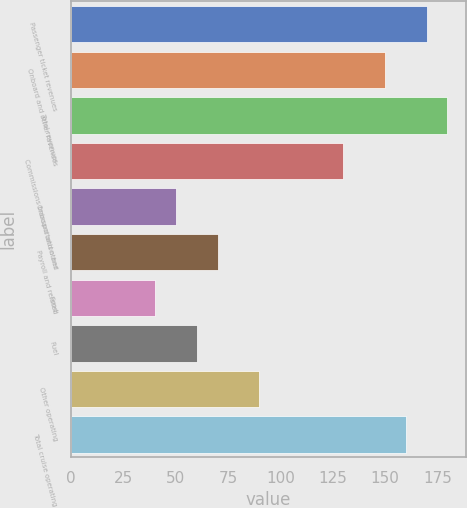Convert chart to OTSL. <chart><loc_0><loc_0><loc_500><loc_500><bar_chart><fcel>Passenger ticket revenues<fcel>Onboard and other revenues<fcel>Total revenues<fcel>Commissions transportation and<fcel>Onboard and other<fcel>Payroll and related<fcel>Food<fcel>Fuel<fcel>Other operating<fcel>Total cruise operating<nl><fcel>169.86<fcel>149.9<fcel>179.84<fcel>129.94<fcel>50.1<fcel>70.06<fcel>40.12<fcel>60.08<fcel>90.02<fcel>159.88<nl></chart> 